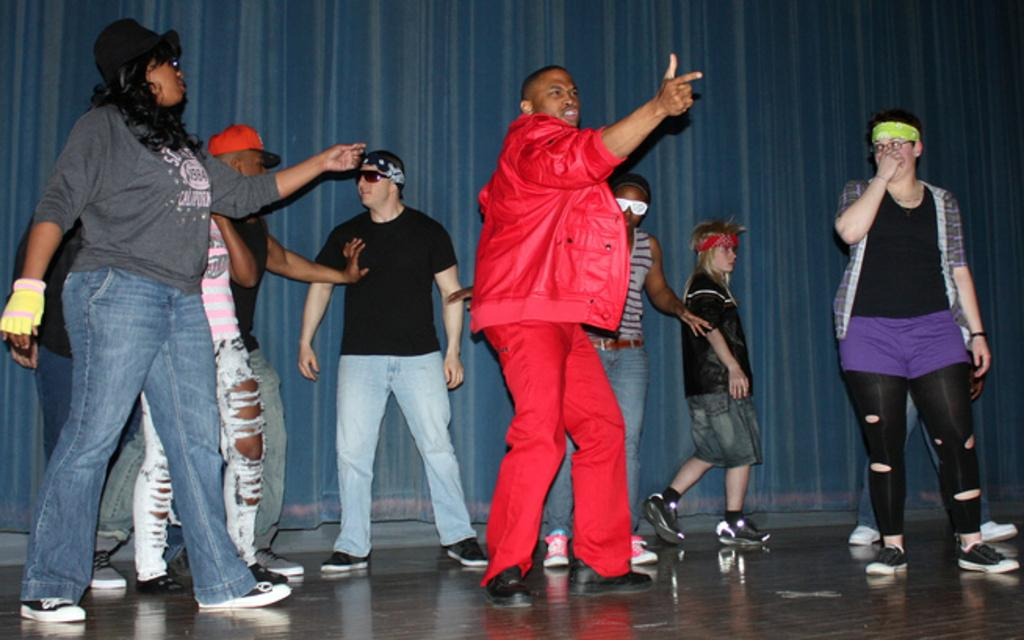What is the main subject of the image? The main subject of the image is the persons in the center of the image. What can be seen in the background of the image? There is a curtain in the background of the image. What is the surface on which the persons are standing? There is a floor at the bottom of the image. How many hens are visible in the image? There are no hens present in the image. What is the rate of the persons in the image? The provided facts do not mention a rate or speed at which the persons are moving or performing any action, so it cannot be determined from the image. 